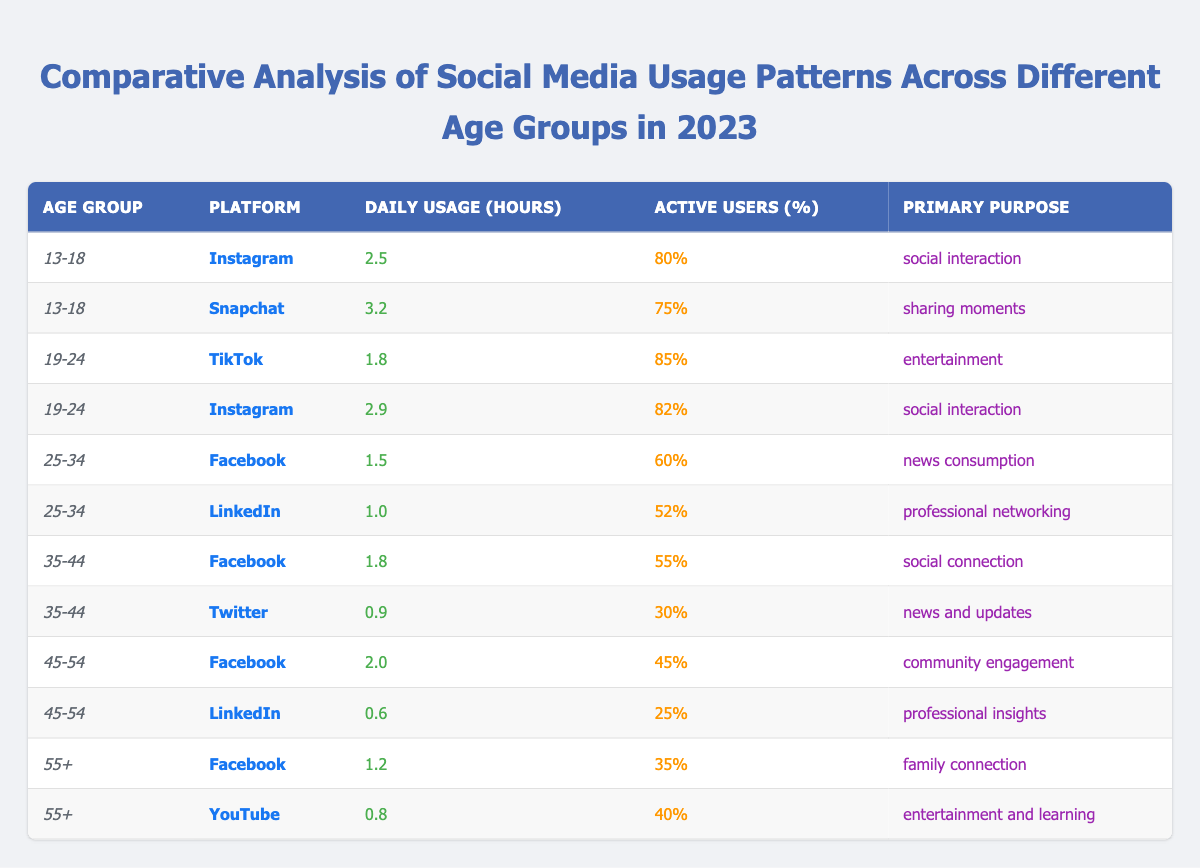What is the daily usage hours of Snapchat for the age group 13-18? According to the table, Snapchat has a daily usage of 3.2 hours for the age group 13-18.
Answer: 3.2 Which platform has the highest percentage of active users in the age group 19-24? Checking the table, TikTok has 85% active users, which is higher than Instagram's 82% for the same age group.
Answer: TikTok What is the primary purpose of Facebook for users aged 25-34? The table states that the primary purpose of Facebook for users aged 25-34 is news consumption.
Answer: News consumption How many platforms have a daily usage of over 2 hours for the age group 45-54? The table shows that only Facebook has a daily usage of 2.0 hours; LinkedIn has only 0.6 hours. Thus, there is 1 platform over 2 hours for this age group.
Answer: 1 What is the difference in daily usage hours between Snapchat and Instagram for the age group 13-18? Snapchat usage is 3.2 hours and Instagram is 2.5 hours. The difference is 3.2 - 2.5 = 0.7 hours.
Answer: 0.7 Which age group has the lowest percentage of active users on LinkedIn? For the age group 55+, the table shows that LinkedIn has 25% active users, which is the lowest among all age groups.
Answer: 55+ What is the average daily usage hours of social media for users aged 35-44? The daily usage hours for this age group are 1.8 (Facebook) and 0.9 (Twitter). The average is (1.8 + 0.9) / 2 = 1.35 hours.
Answer: 1.35 Is the primary purpose of TikTok among 19-24 year-olds social interaction? No, the primary purpose of TikTok is entertainment, as indicated in the table.
Answer: No Which platform is used for family connection by users aged 55+? The table reports that Facebook is used for family connection by the age group 55+.
Answer: Facebook How does the daily usage of YouTube compare to Instagram for the 55+ age group? YouTube usage is 0.8 hours and Instagram is not listed for this age group, so we only refer to the available data. Since Instagram is absent, we can't compare it directly.
Answer: Not applicable 